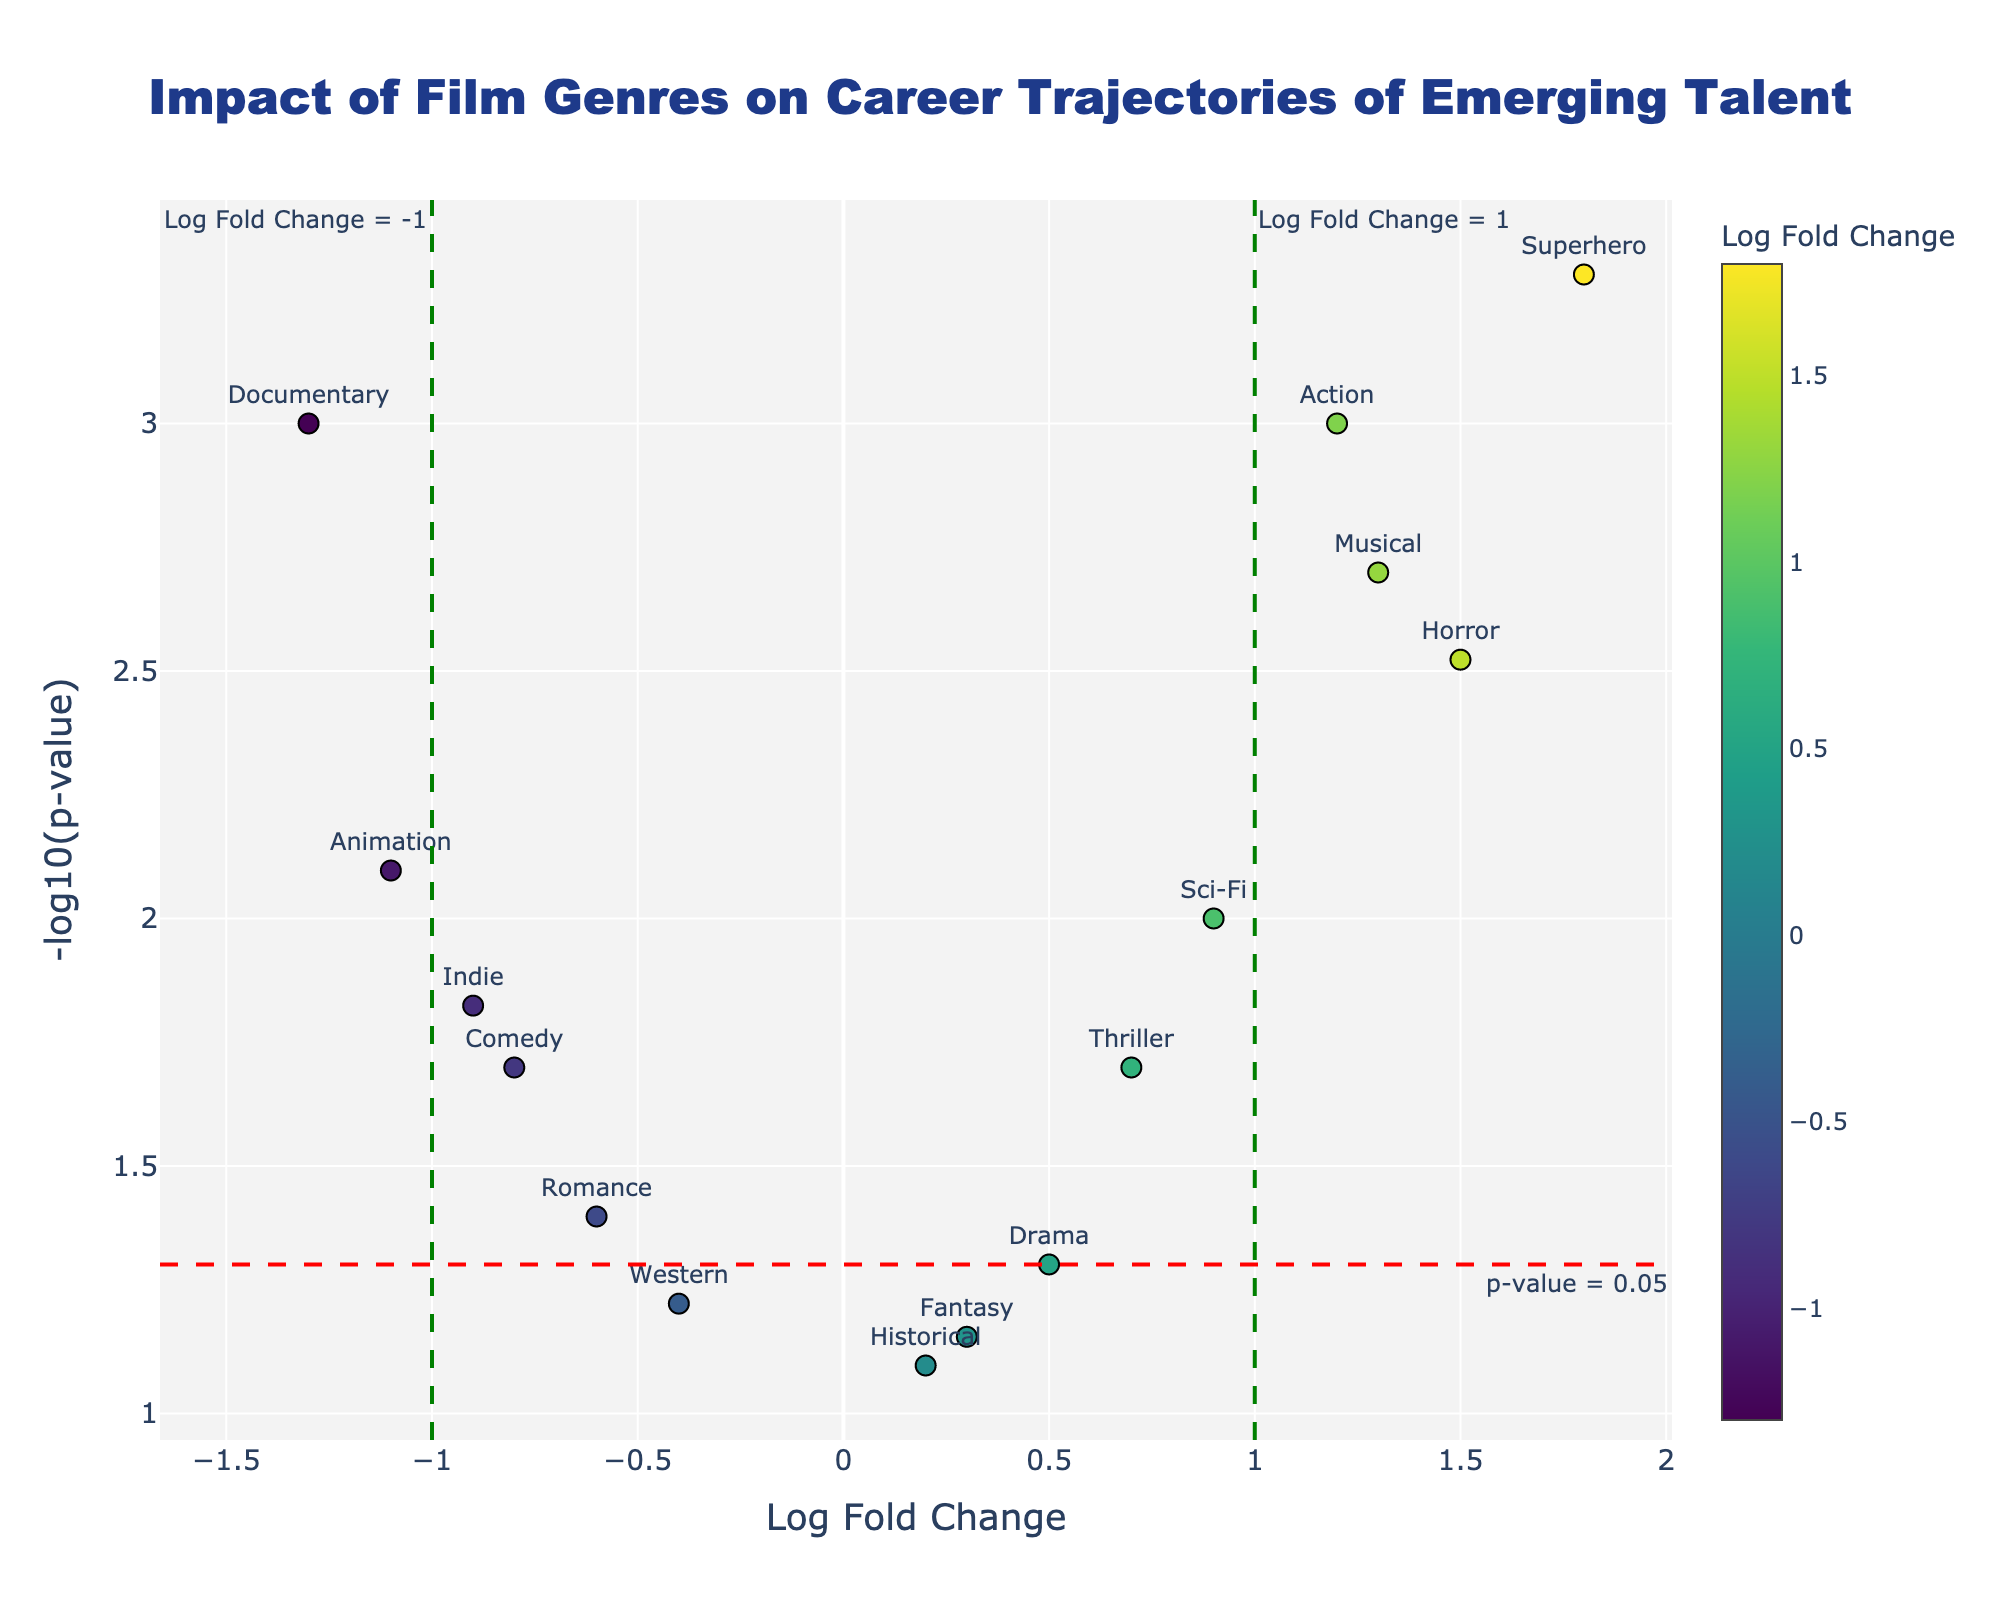What is the title of the plot? The title of the plot is displayed at the top center of the figure and reads "Impact of Film Genres on Career Trajectories of Emerging Talent".
Answer: Impact of Film Genres on Career Trajectories of Emerging Talent Which genres have a Log Fold Change greater than 1? By looking at the plot and finding the data points that are to the right of the vertical line at Log Fold Change = 1, we can identify these genres. They are Horror, Musical, and Superhero.
Answer: Horror, Musical, Superhero What does the red horizontal dashed line represent? The annotation on the figure indicates that the red horizontal dashed line represents where the p-value equals 0.05.
Answer: p-value = 0.05 How many genres have a p-value less than 0.05? To determine this, we need to count the data points that are above the red horizontal dashed line at -log10(p-value) = 1.3 (since -log10(0.05) ≈ 1.3). The genres are Action, Comedy, Horror, Sci-Fi, Musical, Superhero, Animation, Indie, and Documentary. There are 9 genres.
Answer: 9 Which genre has the highest career impact (based on Log Fold Change)? The genre with the highest career impact can be identified by finding the data point farthest to the right on the x-axis. This genre is Superhero with Log Fold Change of 1.8.
Answer: Superhero Which genre has the most negative career impact (based on Log Fold Change)? The genre with the most negative career impact can be identified by finding the data point farthest to the left on the x-axis. This genre is Documentary with Log Fold Change of -1.3.
Answer: Documentary Which genres are considered statistically insignificant based on the p-value? Statistically insignificant genres are those below the red dashed horizontal line (p-value > 0.05). These genres are Drama, Fantasy, Western, and Historical.
Answer: Drama, Fantasy, Western, Historical What is the Log Fold Change and p-value of Musical? By hovering over or identifying the data point for Musical on the plot, we can see that the Log Fold Change is 1.3, and the p-value is 0.002.
Answer: Log Fold Change: 1.3, p-value: 0.002 How many genres have a Log Fold Change between -1 and 1 and a p-value less than 0.05? To determine this, count the data points that are within the vertical green dashed lines (between -1 and 1) and above the red horizontal dashed line (p-value < 0.05). These genres are Drama, Romance, Sci-Fi, and Thriller. There are 4 genres.
Answer: 4 